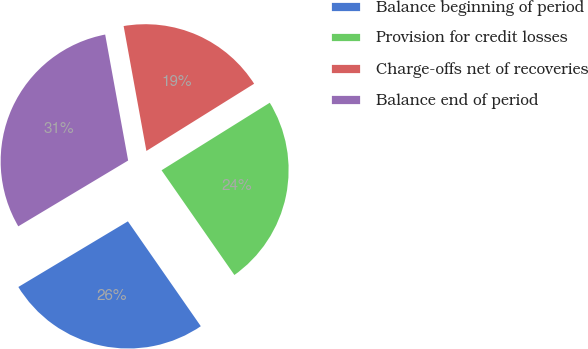Convert chart. <chart><loc_0><loc_0><loc_500><loc_500><pie_chart><fcel>Balance beginning of period<fcel>Provision for credit losses<fcel>Charge-offs net of recoveries<fcel>Balance end of period<nl><fcel>26.08%<fcel>24.21%<fcel>18.99%<fcel>30.72%<nl></chart> 